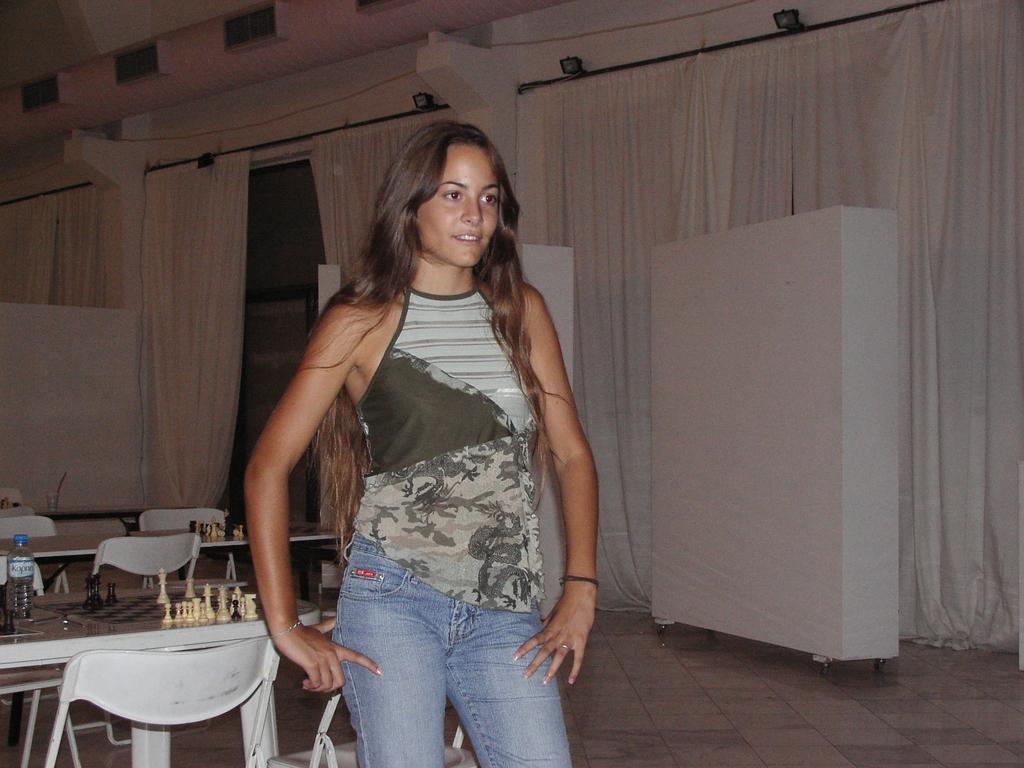Please provide a concise description of this image. In the picture we can see a woman standing, she is wearing a green and white dress, in the background we can see a curtains, cupboard, table, chairs. On the table we can find chess board with a bottles. 